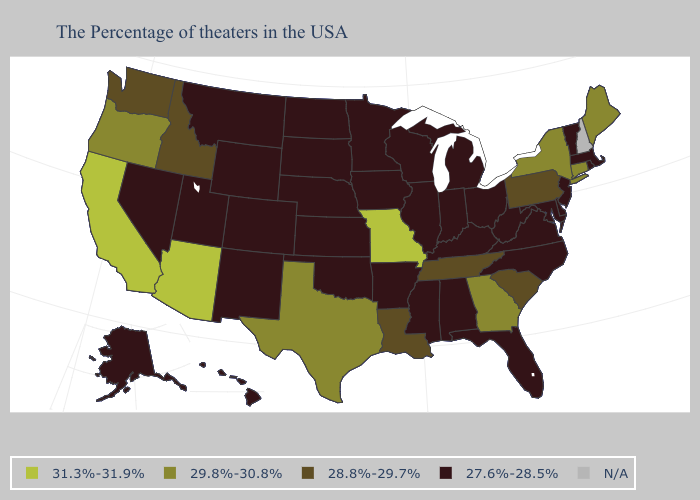Among the states that border Texas , which have the highest value?
Give a very brief answer. Louisiana. Which states have the lowest value in the USA?
Quick response, please. Massachusetts, Rhode Island, Vermont, New Jersey, Delaware, Maryland, Virginia, North Carolina, West Virginia, Ohio, Florida, Michigan, Kentucky, Indiana, Alabama, Wisconsin, Illinois, Mississippi, Arkansas, Minnesota, Iowa, Kansas, Nebraska, Oklahoma, South Dakota, North Dakota, Wyoming, Colorado, New Mexico, Utah, Montana, Nevada, Alaska, Hawaii. Does New Jersey have the highest value in the Northeast?
Answer briefly. No. What is the value of Idaho?
Answer briefly. 28.8%-29.7%. Name the states that have a value in the range 31.3%-31.9%?
Quick response, please. Missouri, Arizona, California. Name the states that have a value in the range 31.3%-31.9%?
Give a very brief answer. Missouri, Arizona, California. Which states have the highest value in the USA?
Write a very short answer. Missouri, Arizona, California. What is the lowest value in the USA?
Quick response, please. 27.6%-28.5%. What is the lowest value in states that border Rhode Island?
Concise answer only. 27.6%-28.5%. Among the states that border Pennsylvania , which have the lowest value?
Write a very short answer. New Jersey, Delaware, Maryland, West Virginia, Ohio. Which states have the lowest value in the USA?
Quick response, please. Massachusetts, Rhode Island, Vermont, New Jersey, Delaware, Maryland, Virginia, North Carolina, West Virginia, Ohio, Florida, Michigan, Kentucky, Indiana, Alabama, Wisconsin, Illinois, Mississippi, Arkansas, Minnesota, Iowa, Kansas, Nebraska, Oklahoma, South Dakota, North Dakota, Wyoming, Colorado, New Mexico, Utah, Montana, Nevada, Alaska, Hawaii. What is the value of Nevada?
Be succinct. 27.6%-28.5%. Does Louisiana have the lowest value in the USA?
Answer briefly. No. 